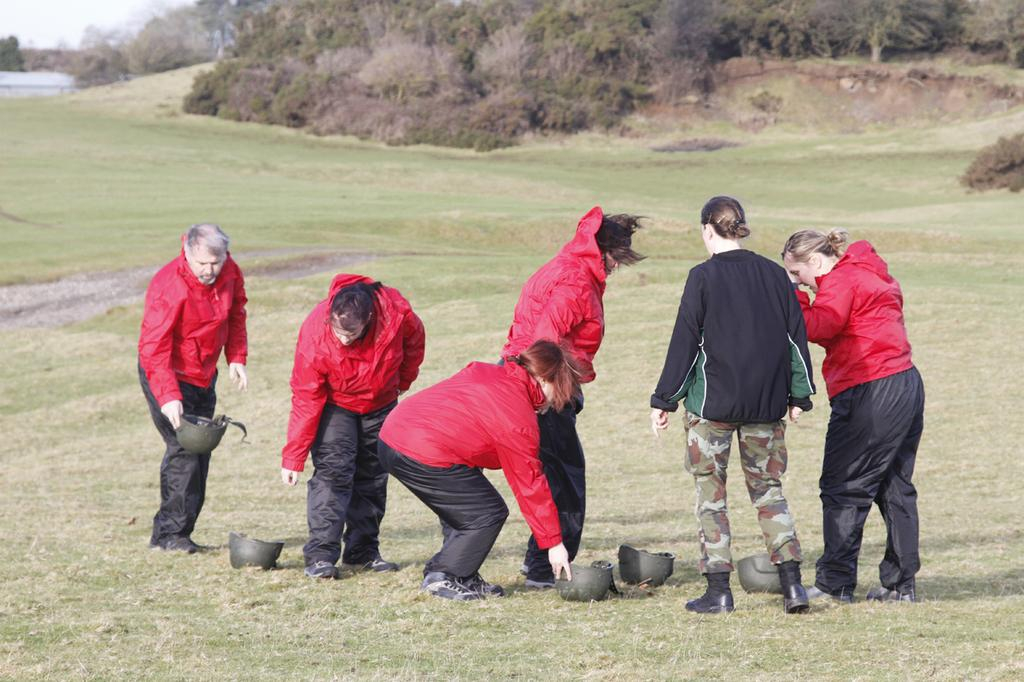What is the setting of the image? The people are standing on a grassland. What are some people holding in their hands? Some people are holding helmets in their hands. Are there any helmets on the ground? Yes, some helmets are placed on the grassland. What can be seen in the background of the image? There are trees in the background of the image. How many frogs can be seen washing their hands in the image? There are no frogs present in the image, and therefore no such activity can be observed. 